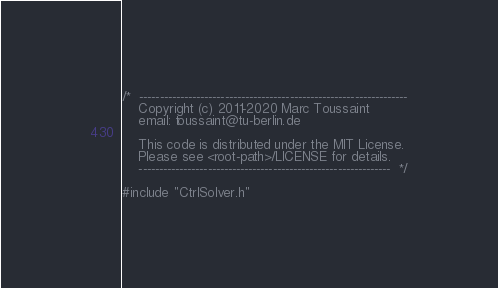<code> <loc_0><loc_0><loc_500><loc_500><_C++_>/*  ------------------------------------------------------------------
    Copyright (c) 2011-2020 Marc Toussaint
    email: toussaint@tu-berlin.de

    This code is distributed under the MIT License.
    Please see <root-path>/LICENSE for details.
    --------------------------------------------------------------  */

#include "CtrlSolver.h"</code> 